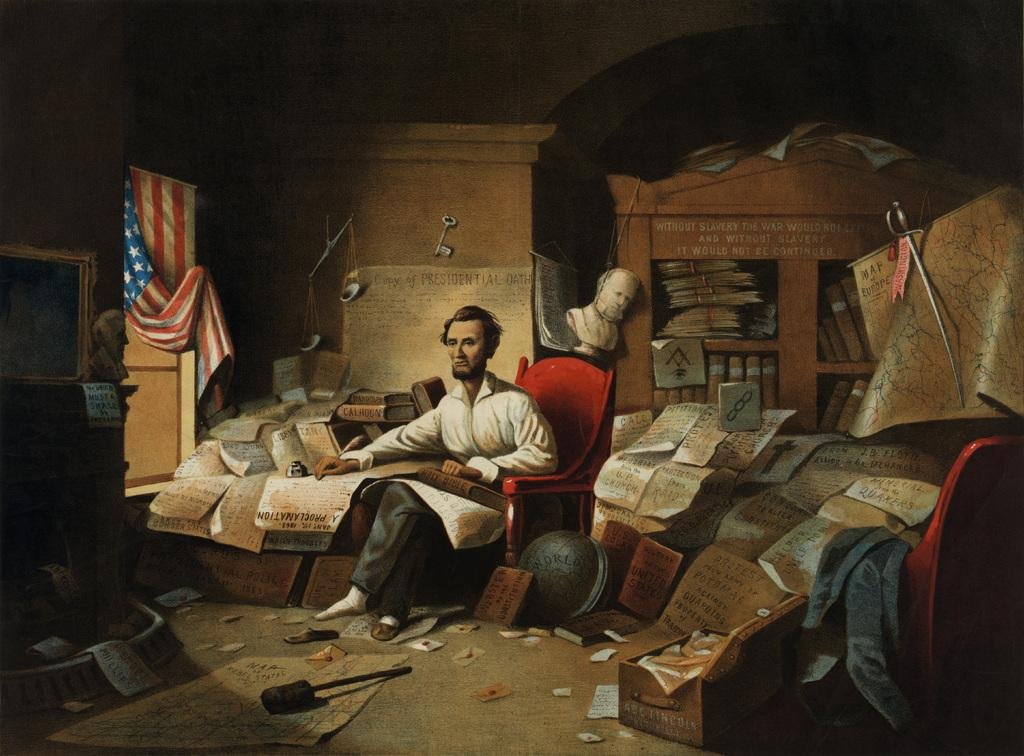What type of objects can be seen in the image? There are mannequins in the image. What other items are present in the image? There is a key, a flag, and a book rack in the image. Where is the mother sitting in the image? There is no mother present in the image. What type of chair is the mannequin sitting on? There are no chairs or mannequins sitting in the image. 